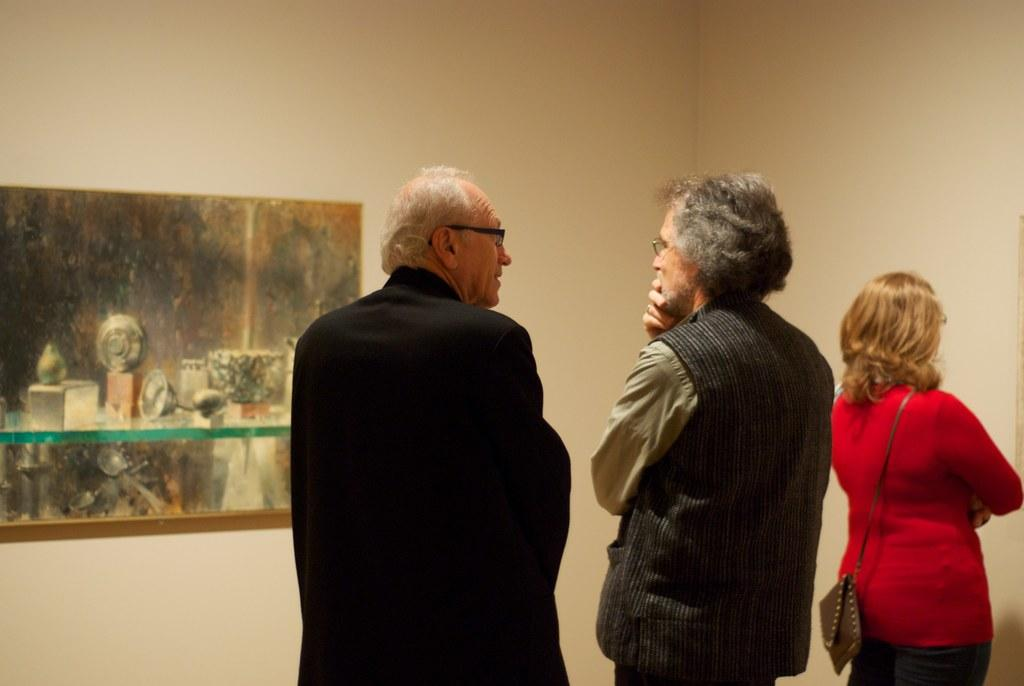How many people are in the image? There are three people standing in the image. Where are the people located in the image? The people are at the bottom of the image. What can be seen in the background of the image? There is a wall in the background of the image. Is there anything attached to the wall in the image? Yes, there is a photo frame attached to the wall. What type of land can be seen in the image? There is no land visible in the image; it features three people standing and a wall with a photo frame in the background. 